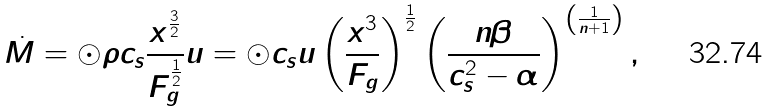Convert formula to latex. <formula><loc_0><loc_0><loc_500><loc_500>\dot { M } = \odot \rho c _ { s } \frac { x ^ { \frac { 3 } { 2 } } } { F _ { g } ^ { \frac { 1 } { 2 } } } u = \odot c _ { s } u \left ( \frac { x ^ { 3 } } { F _ { g } } \right ) ^ { \frac { 1 } { 2 } } \left ( \frac { n \beta } { c _ { s } ^ { 2 } - \alpha } \right ) ^ { \left ( \frac { 1 } { n + 1 } \right ) } ,</formula> 